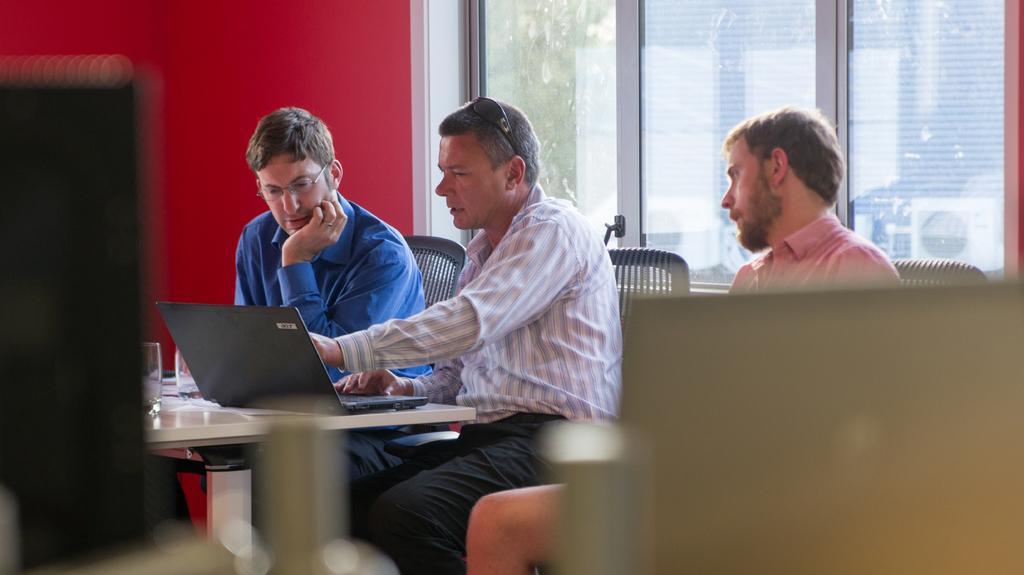In one or two sentences, can you explain what this image depicts? These three persons are sitting on chairs and looking at this laptops. This man wore goggles and pointing out on this laptop. In-front of them there is a table, on this table there is a laptop and glasses. The wall is in red color. From this window we can able to see building and tree. 